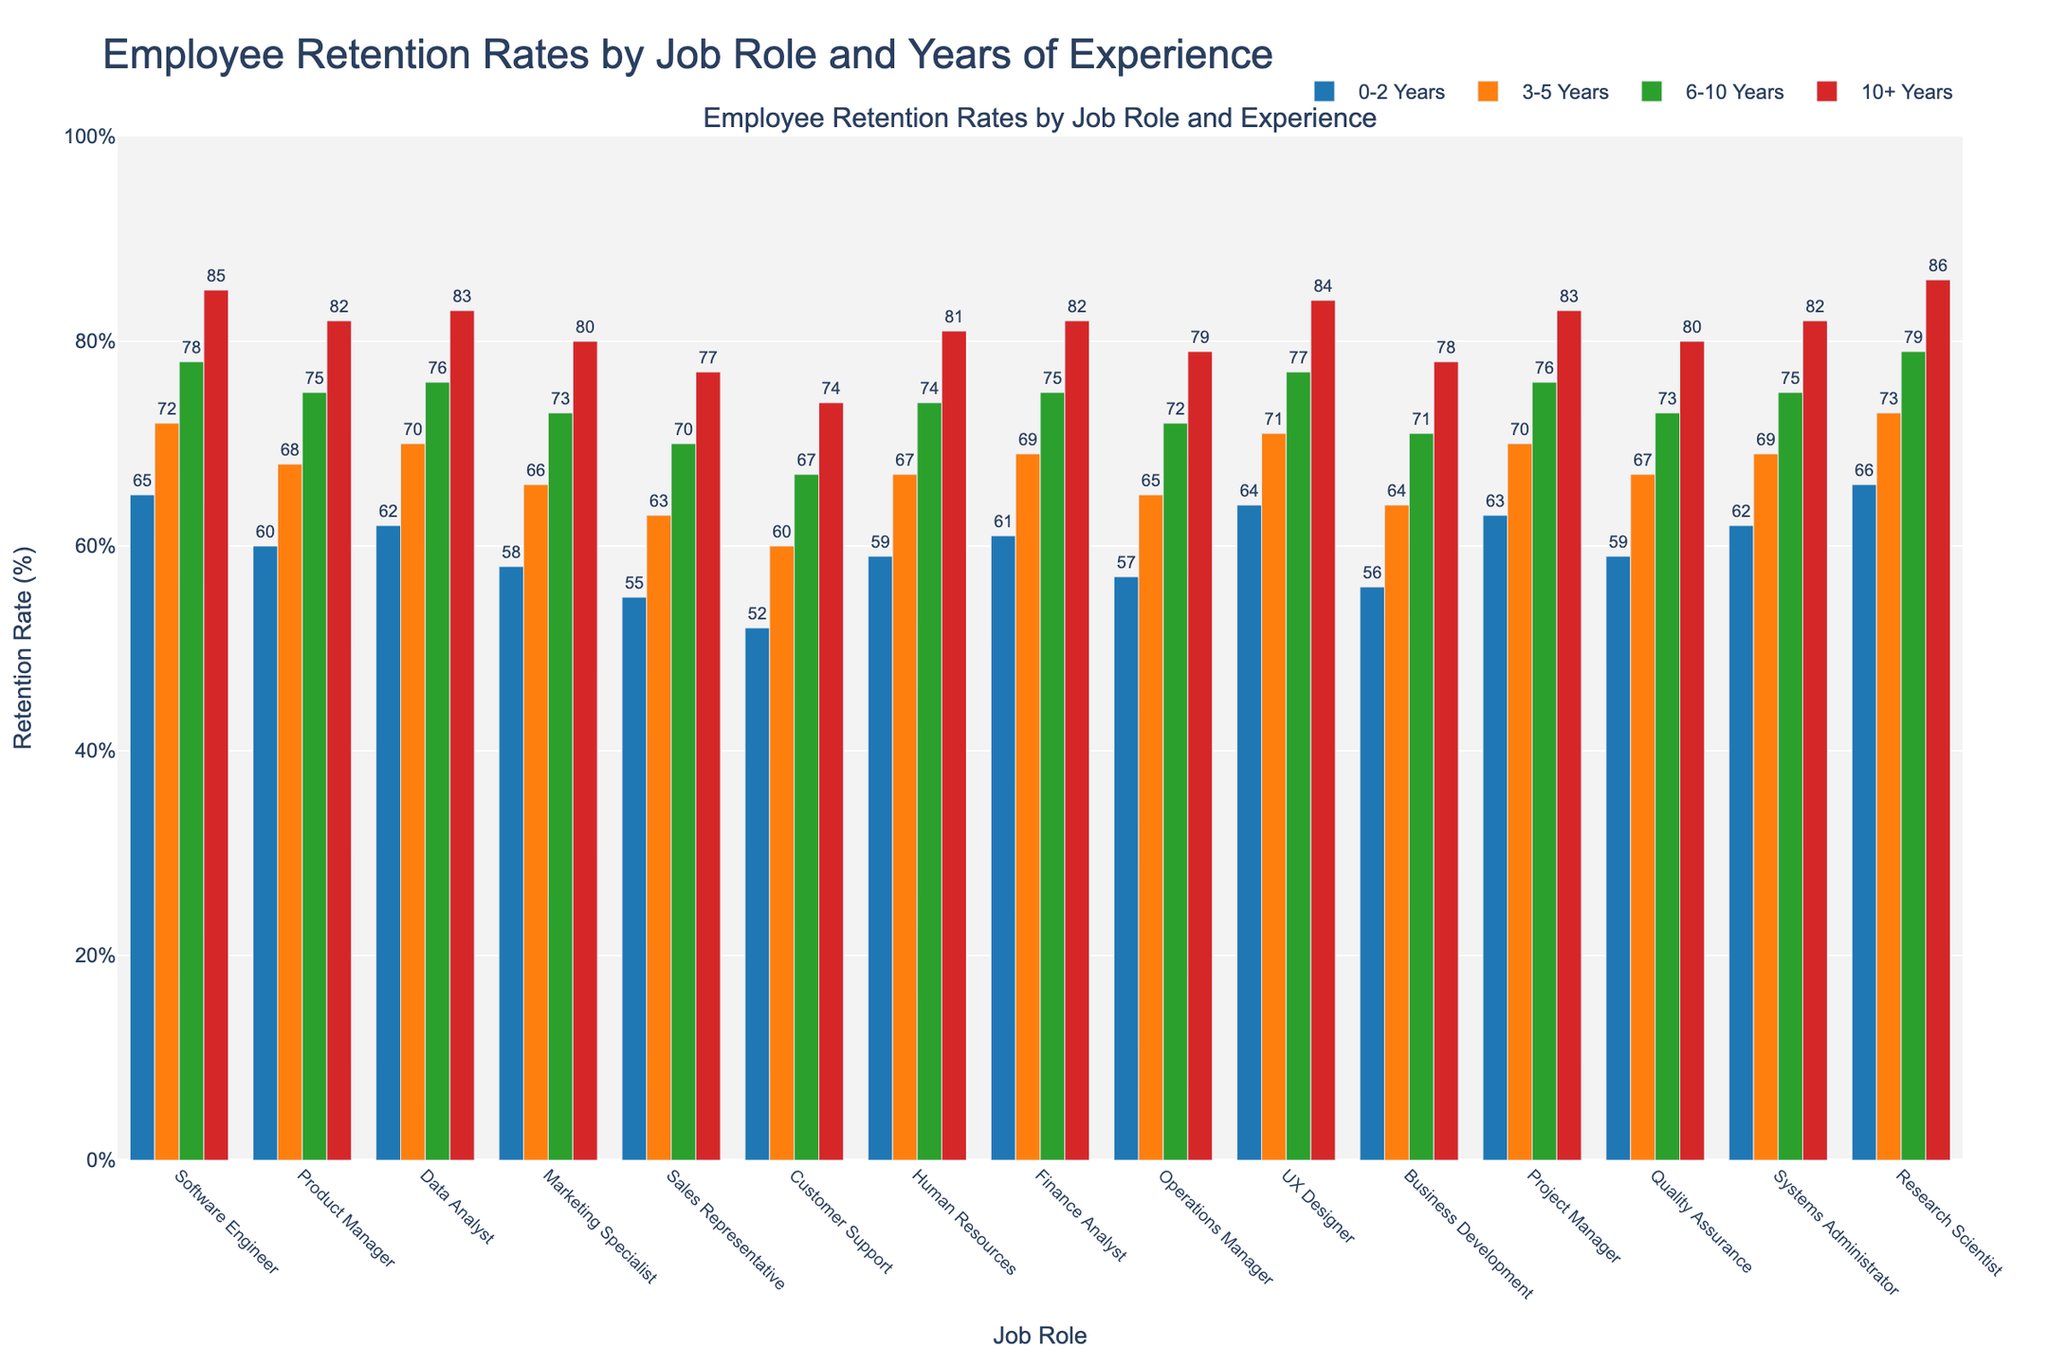Which job role has the highest retention rate for employees with 10+ years of experience? The bar for Research Scientist at 10+ years shows the highest retention rate compared to other bars in the same category.
Answer: Research Scientist Which job role has the lowest retention rate for employees with 0-2 years of experience? The bar for Customer Support at 0-2 years is the lowest among all other 0-2 years bars.
Answer: Customer Support How does the retention rate for Product Managers with 6-10 years of experience compare to that of Software Engineers with the same experience? Product Managers have a retention rate of 75%, while Software Engineers have 78%, so Software Engineers have a higher retention rate.
Answer: Software Engineers What is the average retention rate for a Product Manager? Retention rates for Product Managers are 60, 68, 75, and 82. Summing these gives 285. Dividing by 4 (the number of categories), the average is 71.25%.
Answer: 71.25% Which job role has a greater retention rate difference between the 0-2 years and 10+ years categories, Data Analyst or Marketing Specialist? Data Analyst retention rates are 62% (0-2 years) and 83% (10+ years), with a difference of 21%. Marketing Specialist rates are 58% (0-2 years) and 80% (10+ years), with a difference of 22%. Marketing Specialist has the greater difference.
Answer: Marketing Specialist What is the retention rate range for Finance Analysts? The highest rate for Finance Analysts is 82% (10+ years) and the lowest is 61% (0-2 years). The range is 82% - 61% = 21%.
Answer: 21% How does the retention rate trend for UX Designers change with increasing years of experience? The retention rate for UX Designers increases as years of experience increase: 64% (0-2 years), 71% (3-5 years), 77% (6-10 years), and 84% (10+ years). Each increase is higher than the previous category.
Answer: Increases with experience If the average retention rate of Customer Support with various experiences is calculated, what value would it be? Retention rates for Customer Support are 52% (0-2 years), 60% (3-5 years), 67% (6-10 years), and 74% (10+ years). Their average is (52 + 60 + 67 + 74) / 4 = 63.25%.
Answer: 63.25% What is the retention rate difference between Operations Managers with 0-2 years and Sales Representatives with 10+ years of experience? The retention rate for Operations Managers with 0-2 years is 57%, and for Sales Representatives with 10+ years, it is 77%. The difference is 77% - 57% = 20%.
Answer: 20% Which job role has a more consistent retention rate across all experience levels, Human Resources or Project Manager? Human Resources retention rates are 59% (0-2 years), 67% (3-5 years), 74% (6-10 years), 81% (10+ years). Project Managers have rates of 63% (0-2 years), 70% (3-5 years), 76% (6-10 years), 83% (10+ years). Comparing the variation in their retention rates, Henry Resources are more consistent because there is less percentage variation observed in their retention rates across experience levels.
Answer: Human Resources 